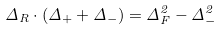Convert formula to latex. <formula><loc_0><loc_0><loc_500><loc_500>\Delta _ { R } \cdot ( \Delta _ { + } + \Delta _ { - } ) = \Delta _ { F } ^ { 2 } - \Delta _ { - } ^ { 2 }</formula> 